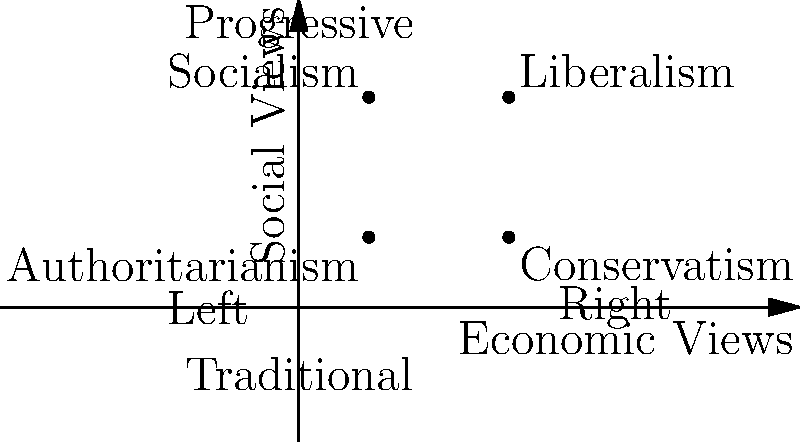Based on the scatter plot of economic and social views, which political ideology is characterized by right-leaning economic policies and traditional social values? To answer this question, we need to analyze the scatter plot and understand the positioning of various political ideologies:

1. The x-axis represents economic views, with left-leaning views on the left and right-leaning views on the right.
2. The y-axis represents social views, with progressive views at the top and traditional views at the bottom.
3. The plot shows four political ideologies: Socialism, Liberalism, Conservatism, and Authoritarianism.

Let's examine each ideology's position:

a) Socialism: Left-leaning economic views, progressive social views
b) Liberalism: Right-leaning economic views, progressive social views
c) Conservatism: Right-leaning economic views, traditional social views
d) Authoritarianism: Left-leaning economic views, traditional social views

The question asks for an ideology with right-leaning economic policies and traditional social values. Looking at the scatter plot, we can see that Conservatism fits this description perfectly, as it is positioned on the right side of the economic axis and the lower part of the social axis.
Answer: Conservatism 